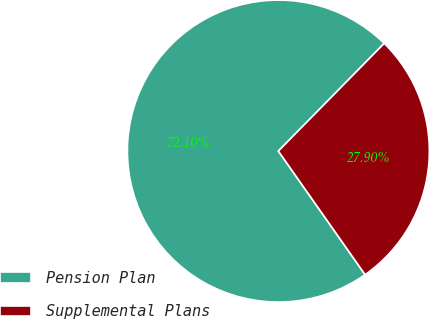<chart> <loc_0><loc_0><loc_500><loc_500><pie_chart><fcel>Pension Plan<fcel>Supplemental Plans<nl><fcel>72.1%<fcel>27.9%<nl></chart> 